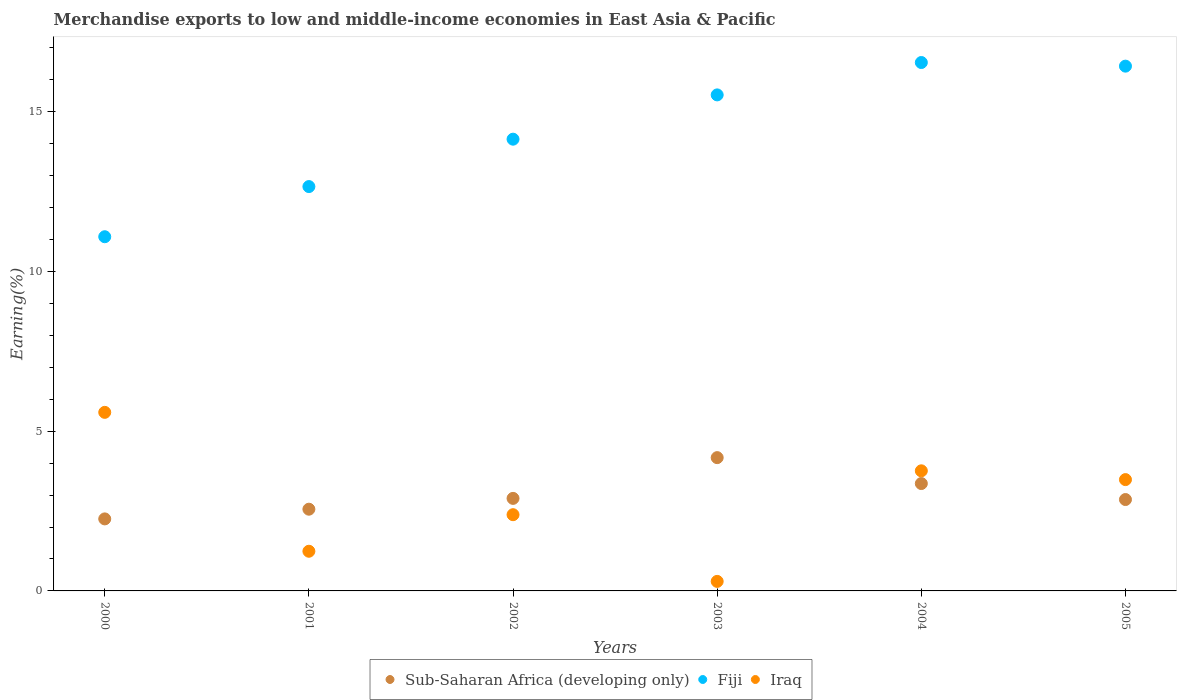How many different coloured dotlines are there?
Provide a succinct answer. 3. Is the number of dotlines equal to the number of legend labels?
Your answer should be compact. Yes. What is the percentage of amount earned from merchandise exports in Fiji in 2005?
Offer a terse response. 16.43. Across all years, what is the maximum percentage of amount earned from merchandise exports in Sub-Saharan Africa (developing only)?
Ensure brevity in your answer.  4.17. Across all years, what is the minimum percentage of amount earned from merchandise exports in Iraq?
Your response must be concise. 0.3. What is the total percentage of amount earned from merchandise exports in Fiji in the graph?
Your answer should be compact. 86.38. What is the difference between the percentage of amount earned from merchandise exports in Sub-Saharan Africa (developing only) in 2001 and that in 2005?
Your response must be concise. -0.3. What is the difference between the percentage of amount earned from merchandise exports in Sub-Saharan Africa (developing only) in 2003 and the percentage of amount earned from merchandise exports in Fiji in 2000?
Provide a succinct answer. -6.92. What is the average percentage of amount earned from merchandise exports in Iraq per year?
Keep it short and to the point. 2.79. In the year 2000, what is the difference between the percentage of amount earned from merchandise exports in Sub-Saharan Africa (developing only) and percentage of amount earned from merchandise exports in Iraq?
Your answer should be very brief. -3.34. In how many years, is the percentage of amount earned from merchandise exports in Sub-Saharan Africa (developing only) greater than 11 %?
Your response must be concise. 0. What is the ratio of the percentage of amount earned from merchandise exports in Iraq in 2001 to that in 2003?
Keep it short and to the point. 4.16. Is the difference between the percentage of amount earned from merchandise exports in Sub-Saharan Africa (developing only) in 2000 and 2002 greater than the difference between the percentage of amount earned from merchandise exports in Iraq in 2000 and 2002?
Your response must be concise. No. What is the difference between the highest and the second highest percentage of amount earned from merchandise exports in Sub-Saharan Africa (developing only)?
Offer a terse response. 0.81. What is the difference between the highest and the lowest percentage of amount earned from merchandise exports in Iraq?
Provide a succinct answer. 5.29. In how many years, is the percentage of amount earned from merchandise exports in Iraq greater than the average percentage of amount earned from merchandise exports in Iraq taken over all years?
Your response must be concise. 3. Is it the case that in every year, the sum of the percentage of amount earned from merchandise exports in Iraq and percentage of amount earned from merchandise exports in Fiji  is greater than the percentage of amount earned from merchandise exports in Sub-Saharan Africa (developing only)?
Your answer should be very brief. Yes. Does the percentage of amount earned from merchandise exports in Sub-Saharan Africa (developing only) monotonically increase over the years?
Ensure brevity in your answer.  No. Is the percentage of amount earned from merchandise exports in Fiji strictly greater than the percentage of amount earned from merchandise exports in Sub-Saharan Africa (developing only) over the years?
Make the answer very short. Yes. Is the percentage of amount earned from merchandise exports in Sub-Saharan Africa (developing only) strictly less than the percentage of amount earned from merchandise exports in Fiji over the years?
Make the answer very short. Yes. How many dotlines are there?
Make the answer very short. 3. How many years are there in the graph?
Ensure brevity in your answer.  6. What is the difference between two consecutive major ticks on the Y-axis?
Your response must be concise. 5. Does the graph contain grids?
Offer a very short reply. No. Where does the legend appear in the graph?
Provide a succinct answer. Bottom center. What is the title of the graph?
Give a very brief answer. Merchandise exports to low and middle-income economies in East Asia & Pacific. Does "Kazakhstan" appear as one of the legend labels in the graph?
Keep it short and to the point. No. What is the label or title of the Y-axis?
Ensure brevity in your answer.  Earning(%). What is the Earning(%) in Sub-Saharan Africa (developing only) in 2000?
Keep it short and to the point. 2.25. What is the Earning(%) in Fiji in 2000?
Your answer should be very brief. 11.09. What is the Earning(%) of Iraq in 2000?
Provide a succinct answer. 5.59. What is the Earning(%) in Sub-Saharan Africa (developing only) in 2001?
Your answer should be very brief. 2.56. What is the Earning(%) of Fiji in 2001?
Your answer should be compact. 12.66. What is the Earning(%) in Iraq in 2001?
Provide a succinct answer. 1.24. What is the Earning(%) of Sub-Saharan Africa (developing only) in 2002?
Make the answer very short. 2.9. What is the Earning(%) of Fiji in 2002?
Keep it short and to the point. 14.14. What is the Earning(%) of Iraq in 2002?
Ensure brevity in your answer.  2.39. What is the Earning(%) in Sub-Saharan Africa (developing only) in 2003?
Provide a succinct answer. 4.17. What is the Earning(%) of Fiji in 2003?
Offer a very short reply. 15.53. What is the Earning(%) in Iraq in 2003?
Your response must be concise. 0.3. What is the Earning(%) of Sub-Saharan Africa (developing only) in 2004?
Offer a very short reply. 3.36. What is the Earning(%) of Fiji in 2004?
Your answer should be compact. 16.54. What is the Earning(%) in Iraq in 2004?
Your response must be concise. 3.76. What is the Earning(%) in Sub-Saharan Africa (developing only) in 2005?
Your answer should be very brief. 2.86. What is the Earning(%) of Fiji in 2005?
Offer a very short reply. 16.43. What is the Earning(%) of Iraq in 2005?
Your response must be concise. 3.48. Across all years, what is the maximum Earning(%) in Sub-Saharan Africa (developing only)?
Keep it short and to the point. 4.17. Across all years, what is the maximum Earning(%) in Fiji?
Provide a short and direct response. 16.54. Across all years, what is the maximum Earning(%) of Iraq?
Your answer should be very brief. 5.59. Across all years, what is the minimum Earning(%) of Sub-Saharan Africa (developing only)?
Provide a short and direct response. 2.25. Across all years, what is the minimum Earning(%) in Fiji?
Provide a succinct answer. 11.09. Across all years, what is the minimum Earning(%) of Iraq?
Your answer should be compact. 0.3. What is the total Earning(%) of Sub-Saharan Africa (developing only) in the graph?
Provide a short and direct response. 18.1. What is the total Earning(%) of Fiji in the graph?
Provide a succinct answer. 86.38. What is the total Earning(%) in Iraq in the graph?
Provide a succinct answer. 16.76. What is the difference between the Earning(%) of Sub-Saharan Africa (developing only) in 2000 and that in 2001?
Ensure brevity in your answer.  -0.3. What is the difference between the Earning(%) in Fiji in 2000 and that in 2001?
Offer a very short reply. -1.57. What is the difference between the Earning(%) in Iraq in 2000 and that in 2001?
Your response must be concise. 4.35. What is the difference between the Earning(%) in Sub-Saharan Africa (developing only) in 2000 and that in 2002?
Provide a succinct answer. -0.64. What is the difference between the Earning(%) of Fiji in 2000 and that in 2002?
Offer a terse response. -3.05. What is the difference between the Earning(%) of Iraq in 2000 and that in 2002?
Offer a terse response. 3.2. What is the difference between the Earning(%) of Sub-Saharan Africa (developing only) in 2000 and that in 2003?
Give a very brief answer. -1.92. What is the difference between the Earning(%) in Fiji in 2000 and that in 2003?
Your response must be concise. -4.44. What is the difference between the Earning(%) in Iraq in 2000 and that in 2003?
Your response must be concise. 5.29. What is the difference between the Earning(%) in Sub-Saharan Africa (developing only) in 2000 and that in 2004?
Your response must be concise. -1.11. What is the difference between the Earning(%) in Fiji in 2000 and that in 2004?
Your answer should be very brief. -5.45. What is the difference between the Earning(%) in Iraq in 2000 and that in 2004?
Provide a short and direct response. 1.83. What is the difference between the Earning(%) in Sub-Saharan Africa (developing only) in 2000 and that in 2005?
Your answer should be compact. -0.61. What is the difference between the Earning(%) of Fiji in 2000 and that in 2005?
Your response must be concise. -5.34. What is the difference between the Earning(%) of Iraq in 2000 and that in 2005?
Make the answer very short. 2.11. What is the difference between the Earning(%) in Sub-Saharan Africa (developing only) in 2001 and that in 2002?
Make the answer very short. -0.34. What is the difference between the Earning(%) of Fiji in 2001 and that in 2002?
Provide a succinct answer. -1.48. What is the difference between the Earning(%) of Iraq in 2001 and that in 2002?
Offer a very short reply. -1.14. What is the difference between the Earning(%) in Sub-Saharan Africa (developing only) in 2001 and that in 2003?
Provide a short and direct response. -1.61. What is the difference between the Earning(%) of Fiji in 2001 and that in 2003?
Your answer should be very brief. -2.87. What is the difference between the Earning(%) of Iraq in 2001 and that in 2003?
Offer a terse response. 0.94. What is the difference between the Earning(%) of Sub-Saharan Africa (developing only) in 2001 and that in 2004?
Offer a terse response. -0.8. What is the difference between the Earning(%) in Fiji in 2001 and that in 2004?
Offer a terse response. -3.88. What is the difference between the Earning(%) in Iraq in 2001 and that in 2004?
Provide a short and direct response. -2.52. What is the difference between the Earning(%) in Sub-Saharan Africa (developing only) in 2001 and that in 2005?
Keep it short and to the point. -0.3. What is the difference between the Earning(%) of Fiji in 2001 and that in 2005?
Offer a terse response. -3.77. What is the difference between the Earning(%) in Iraq in 2001 and that in 2005?
Provide a succinct answer. -2.24. What is the difference between the Earning(%) of Sub-Saharan Africa (developing only) in 2002 and that in 2003?
Provide a succinct answer. -1.28. What is the difference between the Earning(%) of Fiji in 2002 and that in 2003?
Provide a short and direct response. -1.39. What is the difference between the Earning(%) in Iraq in 2002 and that in 2003?
Offer a very short reply. 2.09. What is the difference between the Earning(%) in Sub-Saharan Africa (developing only) in 2002 and that in 2004?
Give a very brief answer. -0.46. What is the difference between the Earning(%) of Fiji in 2002 and that in 2004?
Keep it short and to the point. -2.4. What is the difference between the Earning(%) of Iraq in 2002 and that in 2004?
Keep it short and to the point. -1.37. What is the difference between the Earning(%) of Sub-Saharan Africa (developing only) in 2002 and that in 2005?
Offer a very short reply. 0.04. What is the difference between the Earning(%) of Fiji in 2002 and that in 2005?
Provide a succinct answer. -2.29. What is the difference between the Earning(%) in Iraq in 2002 and that in 2005?
Keep it short and to the point. -1.1. What is the difference between the Earning(%) of Sub-Saharan Africa (developing only) in 2003 and that in 2004?
Make the answer very short. 0.81. What is the difference between the Earning(%) in Fiji in 2003 and that in 2004?
Keep it short and to the point. -1.01. What is the difference between the Earning(%) of Iraq in 2003 and that in 2004?
Provide a short and direct response. -3.46. What is the difference between the Earning(%) in Sub-Saharan Africa (developing only) in 2003 and that in 2005?
Offer a very short reply. 1.31. What is the difference between the Earning(%) in Fiji in 2003 and that in 2005?
Make the answer very short. -0.9. What is the difference between the Earning(%) in Iraq in 2003 and that in 2005?
Offer a terse response. -3.19. What is the difference between the Earning(%) in Sub-Saharan Africa (developing only) in 2004 and that in 2005?
Offer a terse response. 0.5. What is the difference between the Earning(%) in Fiji in 2004 and that in 2005?
Keep it short and to the point. 0.11. What is the difference between the Earning(%) in Iraq in 2004 and that in 2005?
Your response must be concise. 0.28. What is the difference between the Earning(%) in Sub-Saharan Africa (developing only) in 2000 and the Earning(%) in Fiji in 2001?
Your answer should be compact. -10.4. What is the difference between the Earning(%) of Sub-Saharan Africa (developing only) in 2000 and the Earning(%) of Iraq in 2001?
Your answer should be very brief. 1.01. What is the difference between the Earning(%) of Fiji in 2000 and the Earning(%) of Iraq in 2001?
Provide a succinct answer. 9.85. What is the difference between the Earning(%) in Sub-Saharan Africa (developing only) in 2000 and the Earning(%) in Fiji in 2002?
Provide a succinct answer. -11.89. What is the difference between the Earning(%) in Sub-Saharan Africa (developing only) in 2000 and the Earning(%) in Iraq in 2002?
Offer a terse response. -0.13. What is the difference between the Earning(%) of Fiji in 2000 and the Earning(%) of Iraq in 2002?
Keep it short and to the point. 8.7. What is the difference between the Earning(%) of Sub-Saharan Africa (developing only) in 2000 and the Earning(%) of Fiji in 2003?
Ensure brevity in your answer.  -13.27. What is the difference between the Earning(%) in Sub-Saharan Africa (developing only) in 2000 and the Earning(%) in Iraq in 2003?
Make the answer very short. 1.96. What is the difference between the Earning(%) of Fiji in 2000 and the Earning(%) of Iraq in 2003?
Make the answer very short. 10.79. What is the difference between the Earning(%) of Sub-Saharan Africa (developing only) in 2000 and the Earning(%) of Fiji in 2004?
Your answer should be very brief. -14.29. What is the difference between the Earning(%) in Sub-Saharan Africa (developing only) in 2000 and the Earning(%) in Iraq in 2004?
Ensure brevity in your answer.  -1.5. What is the difference between the Earning(%) of Fiji in 2000 and the Earning(%) of Iraq in 2004?
Your answer should be very brief. 7.33. What is the difference between the Earning(%) of Sub-Saharan Africa (developing only) in 2000 and the Earning(%) of Fiji in 2005?
Ensure brevity in your answer.  -14.17. What is the difference between the Earning(%) in Sub-Saharan Africa (developing only) in 2000 and the Earning(%) in Iraq in 2005?
Give a very brief answer. -1.23. What is the difference between the Earning(%) of Fiji in 2000 and the Earning(%) of Iraq in 2005?
Keep it short and to the point. 7.6. What is the difference between the Earning(%) in Sub-Saharan Africa (developing only) in 2001 and the Earning(%) in Fiji in 2002?
Provide a succinct answer. -11.58. What is the difference between the Earning(%) of Sub-Saharan Africa (developing only) in 2001 and the Earning(%) of Iraq in 2002?
Provide a succinct answer. 0.17. What is the difference between the Earning(%) in Fiji in 2001 and the Earning(%) in Iraq in 2002?
Your answer should be very brief. 10.27. What is the difference between the Earning(%) of Sub-Saharan Africa (developing only) in 2001 and the Earning(%) of Fiji in 2003?
Keep it short and to the point. -12.97. What is the difference between the Earning(%) in Sub-Saharan Africa (developing only) in 2001 and the Earning(%) in Iraq in 2003?
Ensure brevity in your answer.  2.26. What is the difference between the Earning(%) of Fiji in 2001 and the Earning(%) of Iraq in 2003?
Offer a very short reply. 12.36. What is the difference between the Earning(%) of Sub-Saharan Africa (developing only) in 2001 and the Earning(%) of Fiji in 2004?
Keep it short and to the point. -13.98. What is the difference between the Earning(%) in Sub-Saharan Africa (developing only) in 2001 and the Earning(%) in Iraq in 2004?
Keep it short and to the point. -1.2. What is the difference between the Earning(%) of Fiji in 2001 and the Earning(%) of Iraq in 2004?
Provide a succinct answer. 8.9. What is the difference between the Earning(%) in Sub-Saharan Africa (developing only) in 2001 and the Earning(%) in Fiji in 2005?
Your answer should be compact. -13.87. What is the difference between the Earning(%) of Sub-Saharan Africa (developing only) in 2001 and the Earning(%) of Iraq in 2005?
Provide a short and direct response. -0.93. What is the difference between the Earning(%) of Fiji in 2001 and the Earning(%) of Iraq in 2005?
Make the answer very short. 9.17. What is the difference between the Earning(%) in Sub-Saharan Africa (developing only) in 2002 and the Earning(%) in Fiji in 2003?
Ensure brevity in your answer.  -12.63. What is the difference between the Earning(%) in Sub-Saharan Africa (developing only) in 2002 and the Earning(%) in Iraq in 2003?
Give a very brief answer. 2.6. What is the difference between the Earning(%) of Fiji in 2002 and the Earning(%) of Iraq in 2003?
Ensure brevity in your answer.  13.84. What is the difference between the Earning(%) of Sub-Saharan Africa (developing only) in 2002 and the Earning(%) of Fiji in 2004?
Make the answer very short. -13.64. What is the difference between the Earning(%) of Sub-Saharan Africa (developing only) in 2002 and the Earning(%) of Iraq in 2004?
Make the answer very short. -0.86. What is the difference between the Earning(%) in Fiji in 2002 and the Earning(%) in Iraq in 2004?
Keep it short and to the point. 10.38. What is the difference between the Earning(%) of Sub-Saharan Africa (developing only) in 2002 and the Earning(%) of Fiji in 2005?
Offer a very short reply. -13.53. What is the difference between the Earning(%) of Sub-Saharan Africa (developing only) in 2002 and the Earning(%) of Iraq in 2005?
Make the answer very short. -0.59. What is the difference between the Earning(%) of Fiji in 2002 and the Earning(%) of Iraq in 2005?
Make the answer very short. 10.66. What is the difference between the Earning(%) in Sub-Saharan Africa (developing only) in 2003 and the Earning(%) in Fiji in 2004?
Your answer should be compact. -12.37. What is the difference between the Earning(%) in Sub-Saharan Africa (developing only) in 2003 and the Earning(%) in Iraq in 2004?
Give a very brief answer. 0.41. What is the difference between the Earning(%) in Fiji in 2003 and the Earning(%) in Iraq in 2004?
Make the answer very short. 11.77. What is the difference between the Earning(%) in Sub-Saharan Africa (developing only) in 2003 and the Earning(%) in Fiji in 2005?
Your answer should be compact. -12.26. What is the difference between the Earning(%) in Sub-Saharan Africa (developing only) in 2003 and the Earning(%) in Iraq in 2005?
Offer a very short reply. 0.69. What is the difference between the Earning(%) in Fiji in 2003 and the Earning(%) in Iraq in 2005?
Ensure brevity in your answer.  12.04. What is the difference between the Earning(%) in Sub-Saharan Africa (developing only) in 2004 and the Earning(%) in Fiji in 2005?
Keep it short and to the point. -13.07. What is the difference between the Earning(%) in Sub-Saharan Africa (developing only) in 2004 and the Earning(%) in Iraq in 2005?
Make the answer very short. -0.12. What is the difference between the Earning(%) of Fiji in 2004 and the Earning(%) of Iraq in 2005?
Make the answer very short. 13.06. What is the average Earning(%) in Sub-Saharan Africa (developing only) per year?
Your answer should be very brief. 3.02. What is the average Earning(%) in Fiji per year?
Your answer should be compact. 14.4. What is the average Earning(%) of Iraq per year?
Offer a terse response. 2.79. In the year 2000, what is the difference between the Earning(%) in Sub-Saharan Africa (developing only) and Earning(%) in Fiji?
Ensure brevity in your answer.  -8.83. In the year 2000, what is the difference between the Earning(%) in Sub-Saharan Africa (developing only) and Earning(%) in Iraq?
Your answer should be compact. -3.34. In the year 2000, what is the difference between the Earning(%) in Fiji and Earning(%) in Iraq?
Offer a terse response. 5.5. In the year 2001, what is the difference between the Earning(%) in Sub-Saharan Africa (developing only) and Earning(%) in Fiji?
Keep it short and to the point. -10.1. In the year 2001, what is the difference between the Earning(%) of Sub-Saharan Africa (developing only) and Earning(%) of Iraq?
Keep it short and to the point. 1.32. In the year 2001, what is the difference between the Earning(%) of Fiji and Earning(%) of Iraq?
Your response must be concise. 11.42. In the year 2002, what is the difference between the Earning(%) in Sub-Saharan Africa (developing only) and Earning(%) in Fiji?
Provide a short and direct response. -11.24. In the year 2002, what is the difference between the Earning(%) of Sub-Saharan Africa (developing only) and Earning(%) of Iraq?
Offer a terse response. 0.51. In the year 2002, what is the difference between the Earning(%) in Fiji and Earning(%) in Iraq?
Provide a succinct answer. 11.76. In the year 2003, what is the difference between the Earning(%) of Sub-Saharan Africa (developing only) and Earning(%) of Fiji?
Provide a short and direct response. -11.36. In the year 2003, what is the difference between the Earning(%) of Sub-Saharan Africa (developing only) and Earning(%) of Iraq?
Ensure brevity in your answer.  3.87. In the year 2003, what is the difference between the Earning(%) of Fiji and Earning(%) of Iraq?
Your response must be concise. 15.23. In the year 2004, what is the difference between the Earning(%) in Sub-Saharan Africa (developing only) and Earning(%) in Fiji?
Provide a short and direct response. -13.18. In the year 2004, what is the difference between the Earning(%) in Sub-Saharan Africa (developing only) and Earning(%) in Iraq?
Your answer should be compact. -0.4. In the year 2004, what is the difference between the Earning(%) in Fiji and Earning(%) in Iraq?
Ensure brevity in your answer.  12.78. In the year 2005, what is the difference between the Earning(%) of Sub-Saharan Africa (developing only) and Earning(%) of Fiji?
Offer a very short reply. -13.57. In the year 2005, what is the difference between the Earning(%) of Sub-Saharan Africa (developing only) and Earning(%) of Iraq?
Keep it short and to the point. -0.62. In the year 2005, what is the difference between the Earning(%) of Fiji and Earning(%) of Iraq?
Offer a terse response. 12.94. What is the ratio of the Earning(%) of Sub-Saharan Africa (developing only) in 2000 to that in 2001?
Your answer should be very brief. 0.88. What is the ratio of the Earning(%) of Fiji in 2000 to that in 2001?
Provide a succinct answer. 0.88. What is the ratio of the Earning(%) of Iraq in 2000 to that in 2001?
Offer a very short reply. 4.5. What is the ratio of the Earning(%) of Sub-Saharan Africa (developing only) in 2000 to that in 2002?
Your answer should be compact. 0.78. What is the ratio of the Earning(%) of Fiji in 2000 to that in 2002?
Keep it short and to the point. 0.78. What is the ratio of the Earning(%) in Iraq in 2000 to that in 2002?
Your answer should be compact. 2.34. What is the ratio of the Earning(%) in Sub-Saharan Africa (developing only) in 2000 to that in 2003?
Give a very brief answer. 0.54. What is the ratio of the Earning(%) in Fiji in 2000 to that in 2003?
Keep it short and to the point. 0.71. What is the ratio of the Earning(%) in Iraq in 2000 to that in 2003?
Provide a succinct answer. 18.75. What is the ratio of the Earning(%) in Sub-Saharan Africa (developing only) in 2000 to that in 2004?
Your response must be concise. 0.67. What is the ratio of the Earning(%) in Fiji in 2000 to that in 2004?
Your response must be concise. 0.67. What is the ratio of the Earning(%) in Iraq in 2000 to that in 2004?
Your answer should be very brief. 1.49. What is the ratio of the Earning(%) of Sub-Saharan Africa (developing only) in 2000 to that in 2005?
Make the answer very short. 0.79. What is the ratio of the Earning(%) in Fiji in 2000 to that in 2005?
Your answer should be very brief. 0.67. What is the ratio of the Earning(%) of Iraq in 2000 to that in 2005?
Make the answer very short. 1.6. What is the ratio of the Earning(%) of Sub-Saharan Africa (developing only) in 2001 to that in 2002?
Your response must be concise. 0.88. What is the ratio of the Earning(%) in Fiji in 2001 to that in 2002?
Your response must be concise. 0.9. What is the ratio of the Earning(%) in Iraq in 2001 to that in 2002?
Make the answer very short. 0.52. What is the ratio of the Earning(%) of Sub-Saharan Africa (developing only) in 2001 to that in 2003?
Offer a very short reply. 0.61. What is the ratio of the Earning(%) in Fiji in 2001 to that in 2003?
Provide a succinct answer. 0.82. What is the ratio of the Earning(%) of Iraq in 2001 to that in 2003?
Provide a short and direct response. 4.16. What is the ratio of the Earning(%) of Sub-Saharan Africa (developing only) in 2001 to that in 2004?
Give a very brief answer. 0.76. What is the ratio of the Earning(%) in Fiji in 2001 to that in 2004?
Keep it short and to the point. 0.77. What is the ratio of the Earning(%) of Iraq in 2001 to that in 2004?
Keep it short and to the point. 0.33. What is the ratio of the Earning(%) of Sub-Saharan Africa (developing only) in 2001 to that in 2005?
Your response must be concise. 0.89. What is the ratio of the Earning(%) of Fiji in 2001 to that in 2005?
Ensure brevity in your answer.  0.77. What is the ratio of the Earning(%) in Iraq in 2001 to that in 2005?
Your response must be concise. 0.36. What is the ratio of the Earning(%) in Sub-Saharan Africa (developing only) in 2002 to that in 2003?
Ensure brevity in your answer.  0.69. What is the ratio of the Earning(%) in Fiji in 2002 to that in 2003?
Offer a very short reply. 0.91. What is the ratio of the Earning(%) in Iraq in 2002 to that in 2003?
Offer a terse response. 8. What is the ratio of the Earning(%) in Sub-Saharan Africa (developing only) in 2002 to that in 2004?
Your answer should be compact. 0.86. What is the ratio of the Earning(%) in Fiji in 2002 to that in 2004?
Provide a short and direct response. 0.85. What is the ratio of the Earning(%) of Iraq in 2002 to that in 2004?
Make the answer very short. 0.63. What is the ratio of the Earning(%) of Sub-Saharan Africa (developing only) in 2002 to that in 2005?
Make the answer very short. 1.01. What is the ratio of the Earning(%) of Fiji in 2002 to that in 2005?
Keep it short and to the point. 0.86. What is the ratio of the Earning(%) in Iraq in 2002 to that in 2005?
Make the answer very short. 0.68. What is the ratio of the Earning(%) of Sub-Saharan Africa (developing only) in 2003 to that in 2004?
Your answer should be compact. 1.24. What is the ratio of the Earning(%) in Fiji in 2003 to that in 2004?
Keep it short and to the point. 0.94. What is the ratio of the Earning(%) of Iraq in 2003 to that in 2004?
Offer a very short reply. 0.08. What is the ratio of the Earning(%) in Sub-Saharan Africa (developing only) in 2003 to that in 2005?
Keep it short and to the point. 1.46. What is the ratio of the Earning(%) in Fiji in 2003 to that in 2005?
Provide a succinct answer. 0.95. What is the ratio of the Earning(%) of Iraq in 2003 to that in 2005?
Your answer should be compact. 0.09. What is the ratio of the Earning(%) of Sub-Saharan Africa (developing only) in 2004 to that in 2005?
Offer a very short reply. 1.18. What is the ratio of the Earning(%) of Iraq in 2004 to that in 2005?
Provide a succinct answer. 1.08. What is the difference between the highest and the second highest Earning(%) of Sub-Saharan Africa (developing only)?
Your answer should be very brief. 0.81. What is the difference between the highest and the second highest Earning(%) of Fiji?
Provide a short and direct response. 0.11. What is the difference between the highest and the second highest Earning(%) of Iraq?
Your answer should be very brief. 1.83. What is the difference between the highest and the lowest Earning(%) of Sub-Saharan Africa (developing only)?
Ensure brevity in your answer.  1.92. What is the difference between the highest and the lowest Earning(%) in Fiji?
Offer a terse response. 5.45. What is the difference between the highest and the lowest Earning(%) of Iraq?
Your response must be concise. 5.29. 